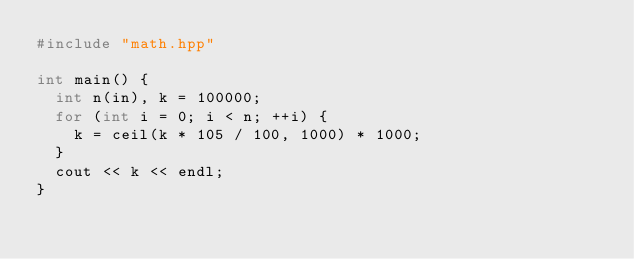Convert code to text. <code><loc_0><loc_0><loc_500><loc_500><_C++_>#include "math.hpp"

int main() {
  int n(in), k = 100000;
  for (int i = 0; i < n; ++i) {
    k = ceil(k * 105 / 100, 1000) * 1000;
  }
  cout << k << endl;
}
</code> 